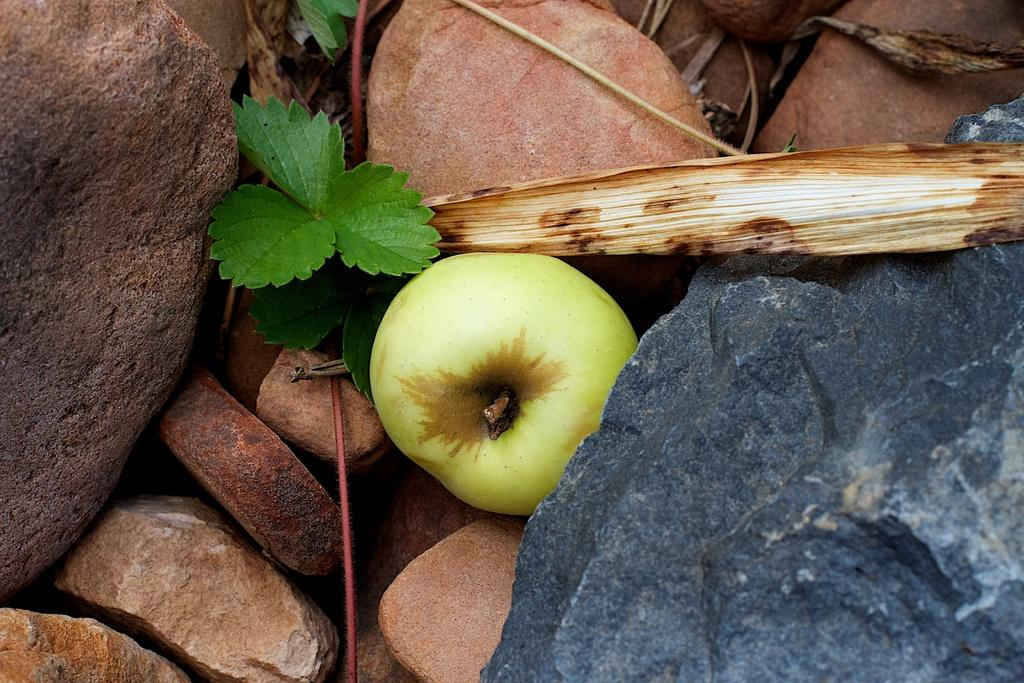What is the main subject in the center of the image? There is an apple in the center of the image. What can be seen on the right side of the image? There are stones on the right side of the image. What can be seen on the left side of the image? There are stones on the left side of the image. What is visible in the background of the image? There are stones and leaves in the background of the image. What type of power is being generated in the image? There is no indication of power generation in the image. The image features an apple and stones in various positions. 